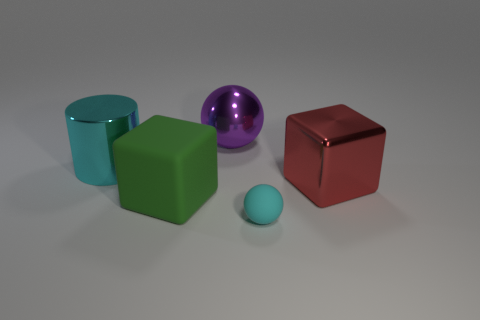There is a metallic object to the left of the large green block; is its color the same as the big rubber cube?
Ensure brevity in your answer.  No. What is the color of the small sphere?
Make the answer very short. Cyan. There is a ball that is behind the cyan matte ball; are there any big purple shiny spheres behind it?
Ensure brevity in your answer.  No. What is the shape of the cyan object that is to the left of the cyan object in front of the large green matte object?
Provide a short and direct response. Cylinder. Are there fewer big brown spheres than purple metal balls?
Offer a terse response. Yes. Does the big purple ball have the same material as the big red thing?
Make the answer very short. Yes. What color is the thing that is in front of the red block and behind the tiny matte ball?
Offer a terse response. Green. Is there a blue matte thing that has the same size as the cyan matte ball?
Give a very brief answer. No. What size is the cyan thing in front of the block right of the small cyan object?
Your response must be concise. Small. Is the number of things behind the cyan matte ball less than the number of large yellow shiny objects?
Your response must be concise. No. 